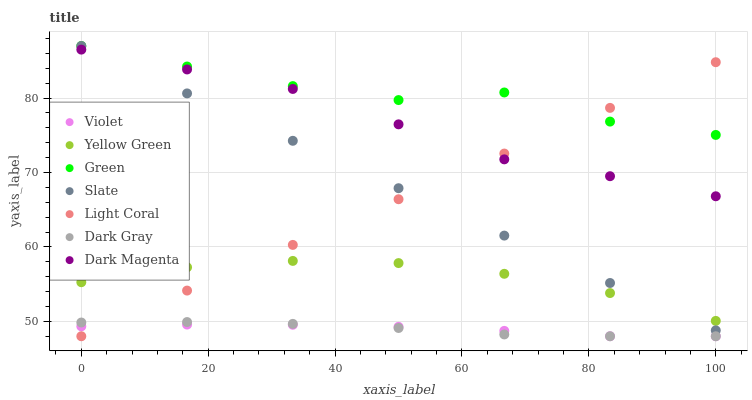Does Violet have the minimum area under the curve?
Answer yes or no. Yes. Does Green have the maximum area under the curve?
Answer yes or no. Yes. Does Yellow Green have the minimum area under the curve?
Answer yes or no. No. Does Yellow Green have the maximum area under the curve?
Answer yes or no. No. Is Light Coral the smoothest?
Answer yes or no. Yes. Is Green the roughest?
Answer yes or no. Yes. Is Yellow Green the smoothest?
Answer yes or no. No. Is Yellow Green the roughest?
Answer yes or no. No. Does Dark Gray have the lowest value?
Answer yes or no. Yes. Does Yellow Green have the lowest value?
Answer yes or no. No. Does Green have the highest value?
Answer yes or no. Yes. Does Yellow Green have the highest value?
Answer yes or no. No. Is Violet less than Yellow Green?
Answer yes or no. Yes. Is Slate greater than Dark Gray?
Answer yes or no. Yes. Does Light Coral intersect Slate?
Answer yes or no. Yes. Is Light Coral less than Slate?
Answer yes or no. No. Is Light Coral greater than Slate?
Answer yes or no. No. Does Violet intersect Yellow Green?
Answer yes or no. No. 